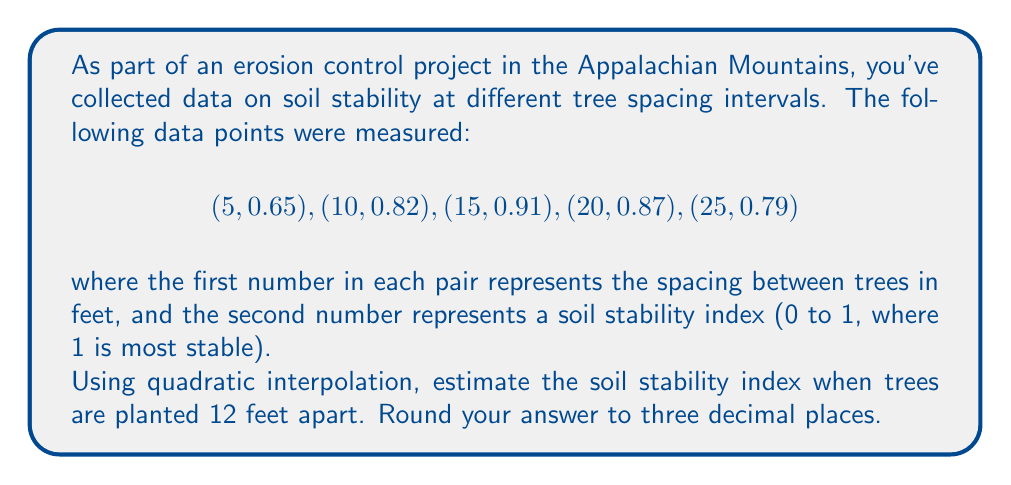Provide a solution to this math problem. To solve this problem using quadratic interpolation, we'll follow these steps:

1) We need to choose three points that surround our target value of 12 feet. Let's use (5, 0.65), (10, 0.82), and (15, 0.91).

2) The quadratic interpolation formula is:

   $$p_2(x) = f(x_0) + f[x_0,x_1](x-x_0) + f[x_0,x_1,x_2](x-x_0)(x-x_1)$$

   where $f[x_0,x_1]$ and $f[x_0,x_1,x_2]$ are divided differences.

3) Calculate the divided differences:

   $$f[x_0,x_1] = \frac{f(x_1) - f(x_0)}{x_1 - x_0} = \frac{0.82 - 0.65}{10 - 5} = 0.034$$

   $$f[x_1,x_2] = \frac{f(x_2) - f(x_1)}{x_2 - x_1} = \frac{0.91 - 0.82}{15 - 10} = 0.018$$

   $$f[x_0,x_1,x_2] = \frac{f[x_1,x_2] - f[x_0,x_1]}{x_2 - x_0} = \frac{0.018 - 0.034}{15 - 5} = -0.0016$$

4) Now we can substitute these values into our quadratic interpolation formula:

   $$p_2(12) = 0.65 + 0.034(12-5) + (-0.0016)(12-5)(12-10)$$

5) Simplify:

   $$p_2(12) = 0.65 + 0.034(7) + (-0.0016)(7)(2)$$
   $$p_2(12) = 0.65 + 0.238 - 0.0224$$
   $$p_2(12) = 0.8656$$

6) Rounding to three decimal places:

   $$p_2(12) \approx 0.866$$
Answer: 0.866 